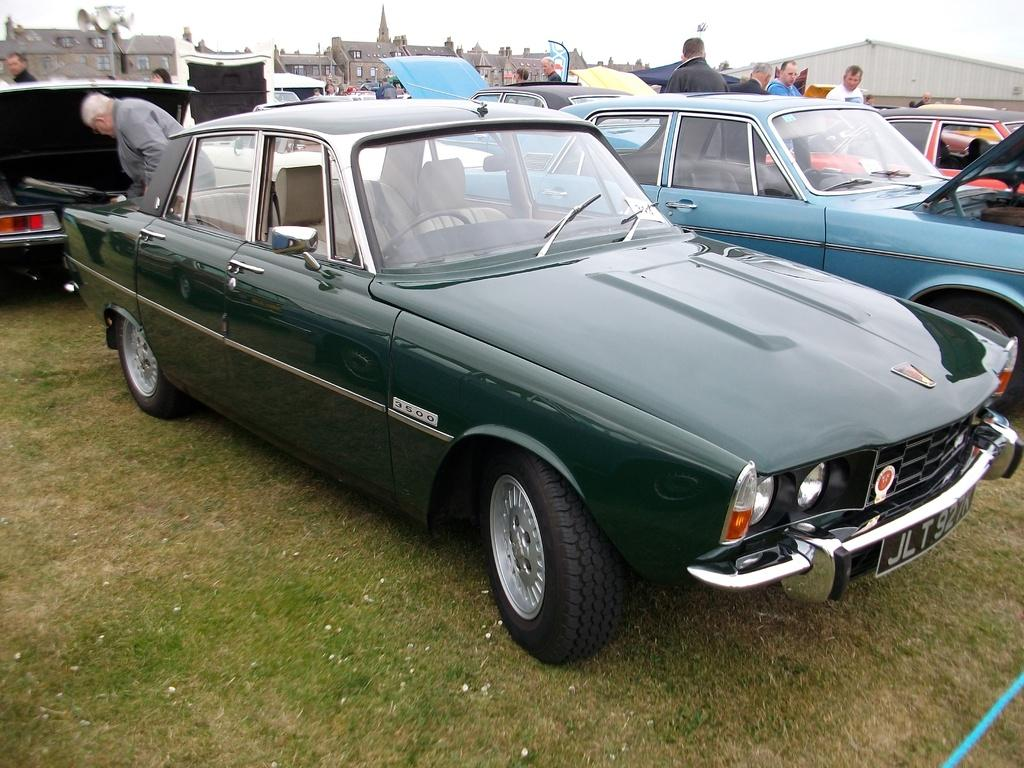What types of vehicles are on the ground in the image? There are motor vehicles on the ground in the image. What else can be seen on the ground besides the vehicles? There are persons standing on the ground in the image. What is attached to the pole in the image? Speakers are attached to a pole in the image. What structures are visible in the image? There are buildings and a shed in the image. What part of the natural environment is visible in the image? The sky is visible in the image. Can you tell me how many mittens are being used for writing in the image? There are no mittens or writing activities present in the image. What type of existence is depicted in the image? The image does not depict any specific type of existence; it shows motor vehicles, persons, speakers, buildings, a shed, and the sky. 